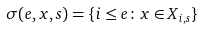<formula> <loc_0><loc_0><loc_500><loc_500>\sigma ( e , x , s ) = \{ i \leq e \colon x \in X _ { i , s } \}</formula> 